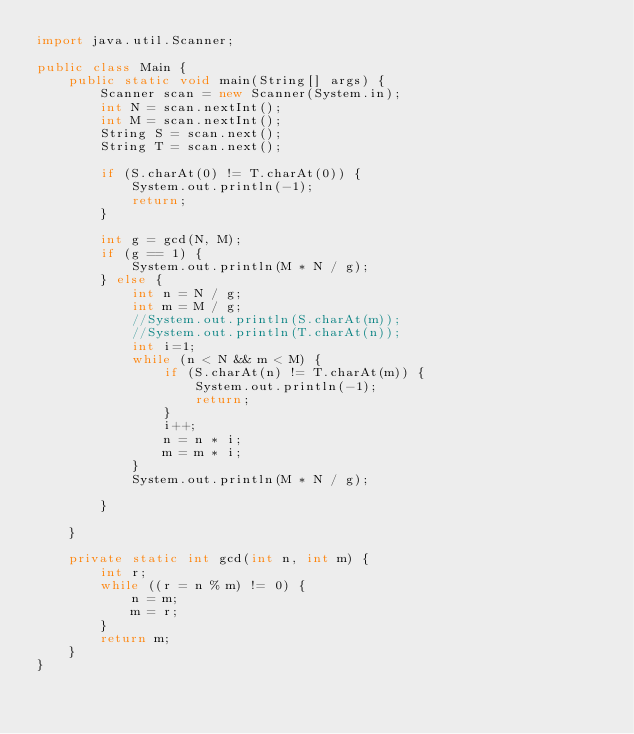Convert code to text. <code><loc_0><loc_0><loc_500><loc_500><_Java_>import java.util.Scanner;

public class Main {
	public static void main(String[] args) {
		Scanner scan = new Scanner(System.in);
		int N = scan.nextInt();
		int M = scan.nextInt();
		String S = scan.next();
		String T = scan.next();

		if (S.charAt(0) != T.charAt(0)) {
			System.out.println(-1);
			return;
		}

		int g = gcd(N, M);
		if (g == 1) {
			System.out.println(M * N / g);
		} else {
			int n = N / g;
			int m = M / g;
			//System.out.println(S.charAt(m));
			//System.out.println(T.charAt(n));
			int i=1;
			while (n < N && m < M) {
				if (S.charAt(n) != T.charAt(m)) {
					System.out.println(-1);
					return;
				}
				i++;
				n = n * i;
				m = m * i;
			}
			System.out.println(M * N / g);

		}

	}

	private static int gcd(int n, int m) {
		int r;
		while ((r = n % m) != 0) {
			n = m;
			m = r;
		}
		return m;
	}
}
</code> 